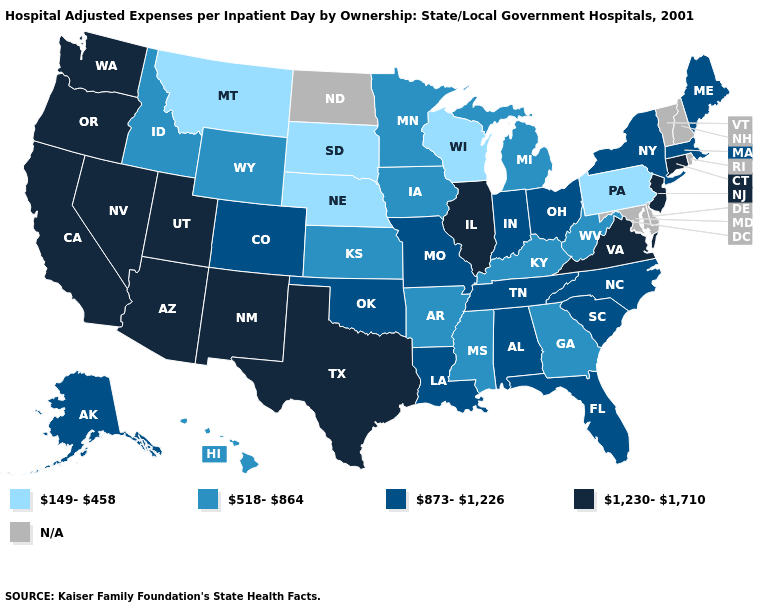Among the states that border West Virginia , does Kentucky have the lowest value?
Answer briefly. No. Name the states that have a value in the range 873-1,226?
Be succinct. Alabama, Alaska, Colorado, Florida, Indiana, Louisiana, Maine, Massachusetts, Missouri, New York, North Carolina, Ohio, Oklahoma, South Carolina, Tennessee. What is the lowest value in the USA?
Give a very brief answer. 149-458. Which states have the lowest value in the USA?
Answer briefly. Montana, Nebraska, Pennsylvania, South Dakota, Wisconsin. Among the states that border Montana , which have the highest value?
Keep it brief. Idaho, Wyoming. Which states have the highest value in the USA?
Keep it brief. Arizona, California, Connecticut, Illinois, Nevada, New Jersey, New Mexico, Oregon, Texas, Utah, Virginia, Washington. What is the lowest value in the USA?
Keep it brief. 149-458. What is the value of Washington?
Give a very brief answer. 1,230-1,710. Name the states that have a value in the range N/A?
Keep it brief. Delaware, Maryland, New Hampshire, North Dakota, Rhode Island, Vermont. Name the states that have a value in the range 518-864?
Keep it brief. Arkansas, Georgia, Hawaii, Idaho, Iowa, Kansas, Kentucky, Michigan, Minnesota, Mississippi, West Virginia, Wyoming. Which states have the lowest value in the MidWest?
Keep it brief. Nebraska, South Dakota, Wisconsin. Among the states that border Utah , does Arizona have the lowest value?
Answer briefly. No. Is the legend a continuous bar?
Keep it brief. No. Name the states that have a value in the range 149-458?
Concise answer only. Montana, Nebraska, Pennsylvania, South Dakota, Wisconsin. What is the value of Texas?
Keep it brief. 1,230-1,710. 